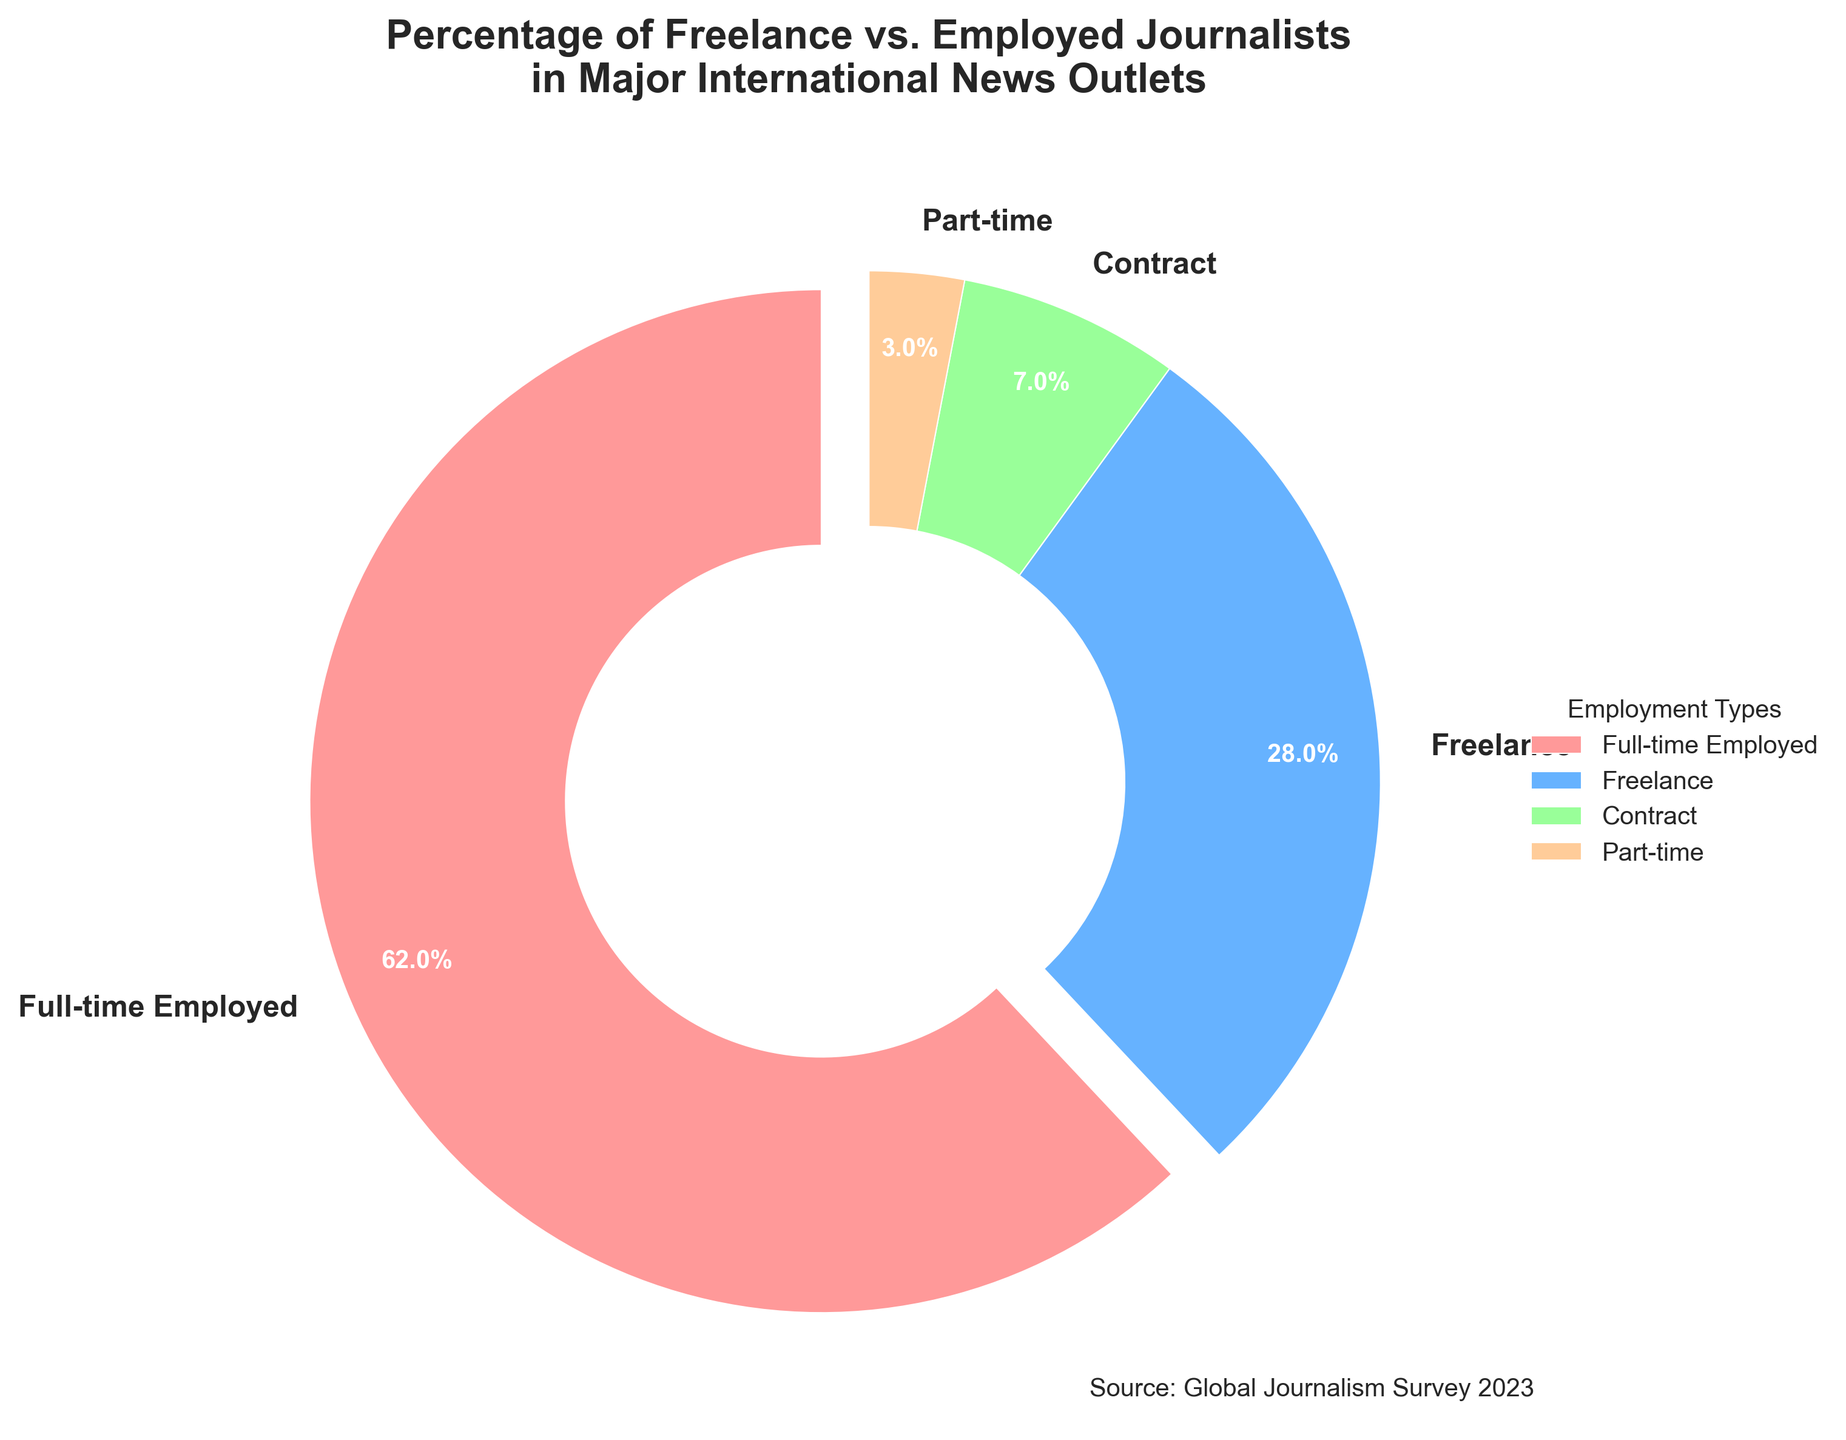What percentage of journalists are full-time employed compared to part-time? First, identify the percentage for full-time employed (62%) and for part-time (3%) from the pie chart. Compare the two values to determine how the full-time employed percentage compares to the part-time percentage.
Answer: 62% vs 3% Which employment type has the smallest share? Look at the percentages on the pie chart for each employment type and identify the smallest value.
Answer: Part-time What is the combined percentage of freelance and contract journalists? Find the percentages for freelance (28%) and contract (7%) from the pie chart. Add these two values together to get the combined percentage.
Answer: 35% How much greater is the percentage of full-time employed journalists compared to freelance journalists? Note the percentage of full-time employed journalists (62%) and freelance journalists (28%). Subtract the freelance percentage from the full-time employed percentage: 62 - 28.
Answer: 34% Which employment type has the bold text in the largest wedge? The largest wedge has the label with the bold text. Identify which type it is from the pie chart.
Answer: Full-time Employed What is the difference between the highest and lowest percentage values? Identify the highest percentage (Full-time Employed: 62%) and the lowest (Part-time: 3%) on the pie chart. Subtract the lowest percentage from the highest: 62 - 3.
Answer: 59% Are contract journalists' percentage figures more or less than 10%? Check the pie chart for the percentage of contract journalists and see if it is above or below 10%. The contract journalists' percentage is 7%.
Answer: Less What color represents freelance journalists? Look at the color associated with the freelance section of the pie chart.
Answer: Blue If a news outlet had 1,000 journalists, approximately how many would be freelance? Use the percentage given for freelance journalists (28%) and calculate 28% of 1,000. 28% of 1,000 is 0.28 * 1,000.
Answer: 280 By how much does the full-time employed percentage exceed half of the total workforce? The full-time employed percentage is 62%. Half of the total workforce (100%) is 50%. Subtract 50% from 62%: 62 - 50.
Answer: 12% 